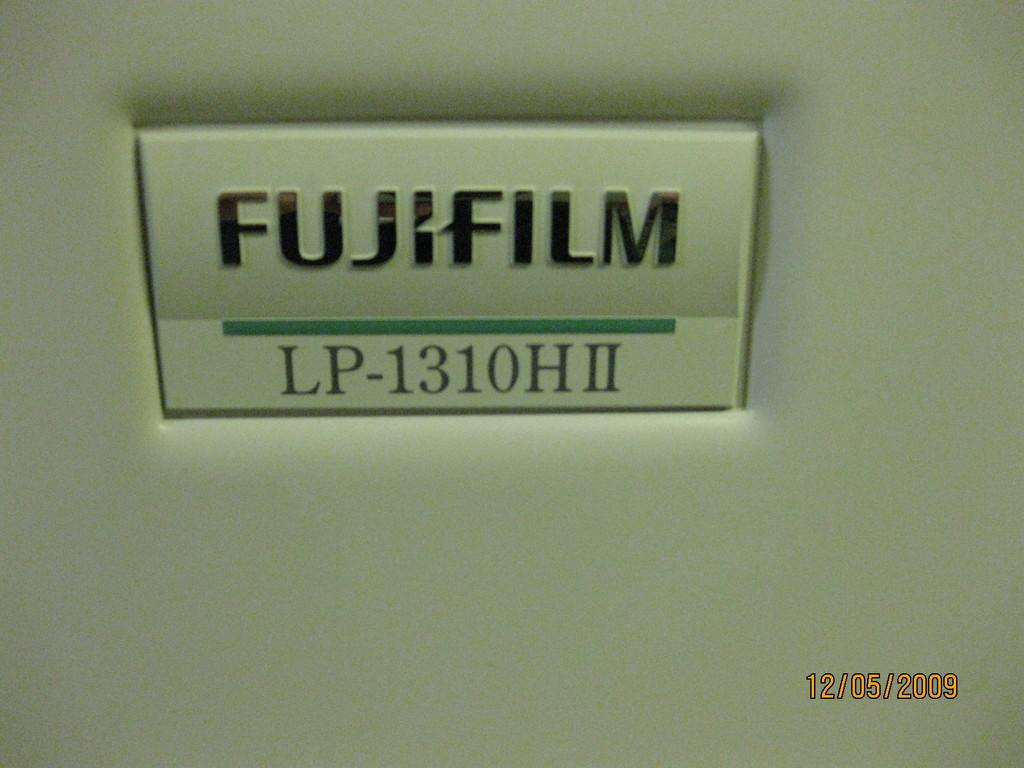What is the color of the object in the image? The object in the image is white. Can you describe any text or writing on the object? Yes, there is writing on the object. How does the boy's interest in planes affect the object in the image? There is no boy or mention of planes in the image, so we cannot determine any effect on the object. 